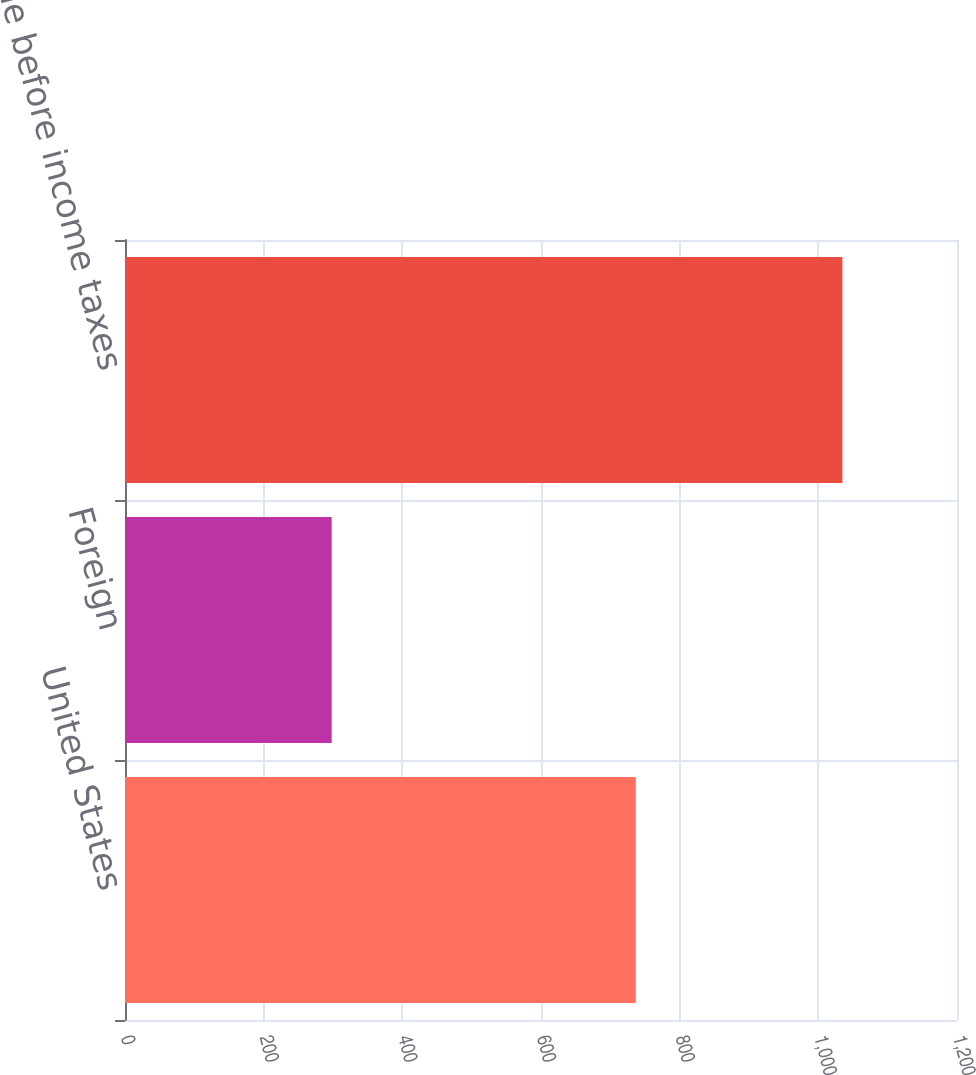Convert chart. <chart><loc_0><loc_0><loc_500><loc_500><bar_chart><fcel>United States<fcel>Foreign<fcel>Income before income taxes<nl><fcel>736.7<fcel>298.1<fcel>1034.8<nl></chart> 